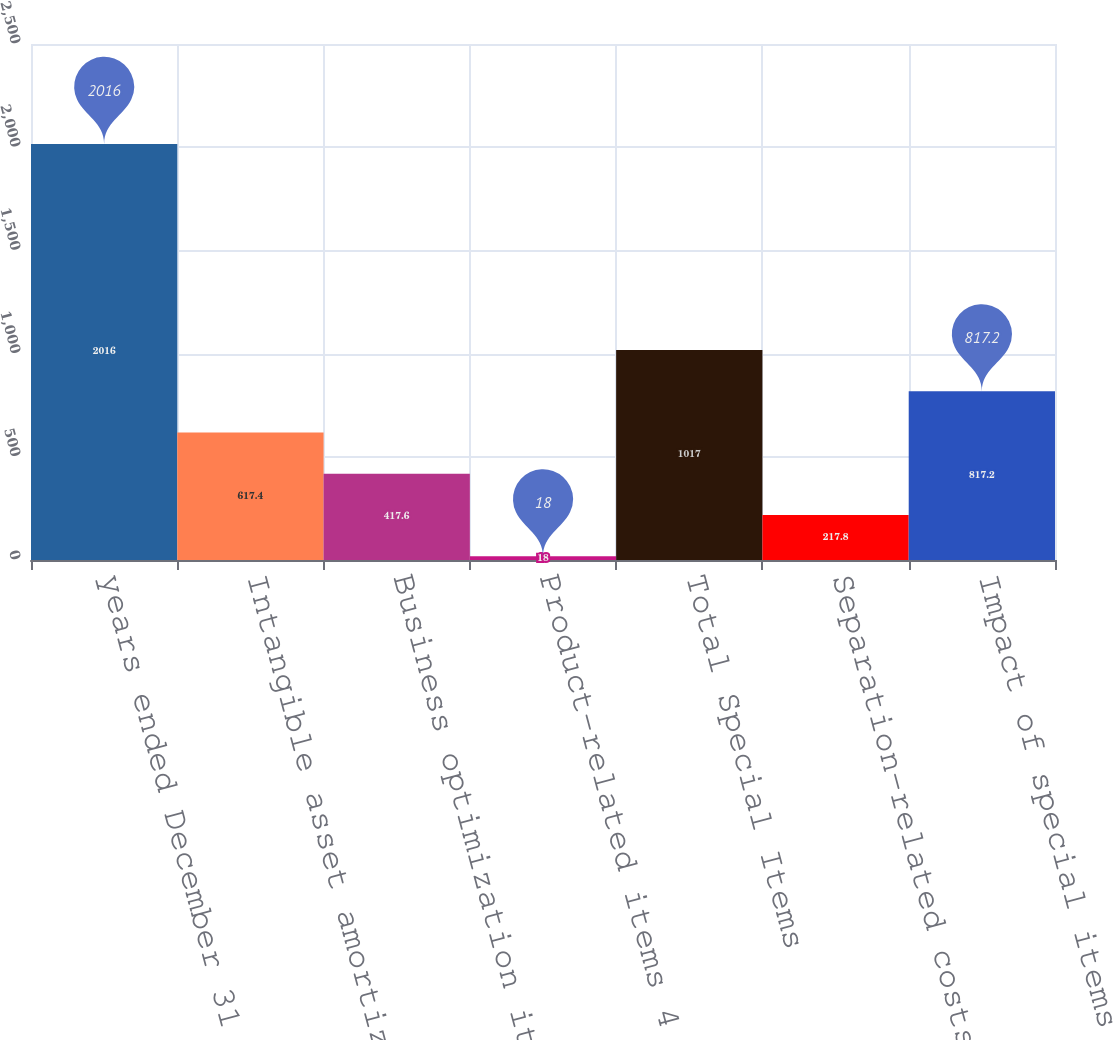Convert chart to OTSL. <chart><loc_0><loc_0><loc_500><loc_500><bar_chart><fcel>years ended December 31 (in<fcel>Intangible asset amortization<fcel>Business optimization items 1<fcel>Product-related items 4<fcel>Total Special Items<fcel>Separation-related costs 3<fcel>Impact of special items 9<nl><fcel>2016<fcel>617.4<fcel>417.6<fcel>18<fcel>1017<fcel>217.8<fcel>817.2<nl></chart> 